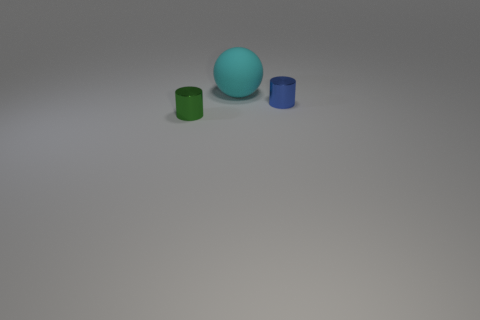Is there anything else that is the same size as the rubber ball?
Offer a terse response. No. Is there anything else that has the same material as the cyan ball?
Offer a very short reply. No. There is a small cylinder that is to the right of the big cyan matte thing; does it have the same color as the thing that is behind the blue object?
Ensure brevity in your answer.  No. What material is the object that is behind the metal object that is behind the tiny metal thing that is left of the blue object made of?
Provide a succinct answer. Rubber. Are there more objects than small cyan metal cylinders?
Keep it short and to the point. Yes. Are there any other things of the same color as the large matte ball?
Make the answer very short. No. There is a green cylinder that is made of the same material as the blue cylinder; what size is it?
Your response must be concise. Small. What material is the small blue cylinder?
Your answer should be compact. Metal. What number of matte objects are the same size as the cyan rubber sphere?
Provide a succinct answer. 0. Is there a big green shiny thing of the same shape as the tiny green object?
Make the answer very short. No. 